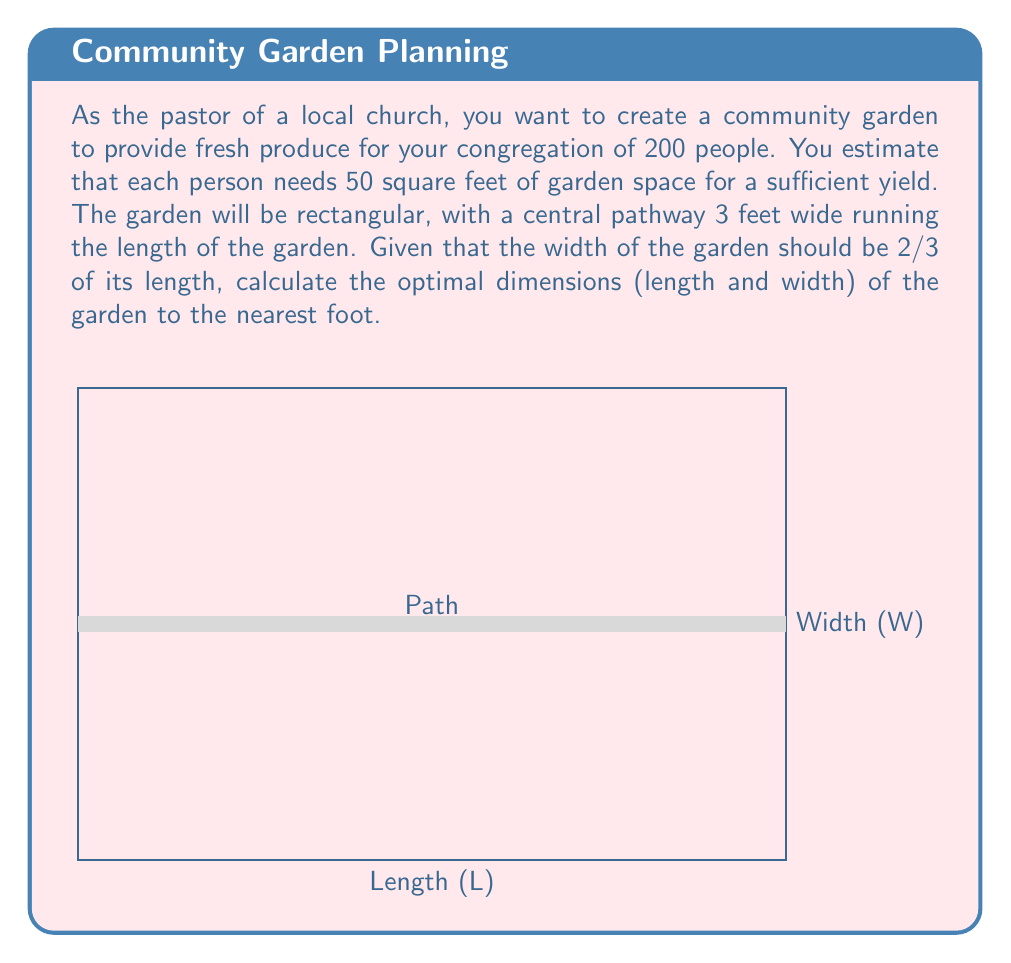Help me with this question. Let's approach this step-by-step:

1) First, calculate the total garden area needed:
   $$\text{Total Area} = 200 \text{ people} \times 50 \text{ sq ft} = 10,000 \text{ sq ft}$$

2) Let L be the length and W be the width of the garden. We're given that W = 2/3 L.

3) The area of the garden minus the path should equal 10,000 sq ft:
   $$L \times W - 3L = 10,000$$

4) Substitute W with 2/3 L:
   $$L \times (2/3L) - 3L = 10,000$$
   $$2/3L^2 - 3L = 10,000$$

5) Multiply all terms by 3:
   $$2L^2 - 9L - 30,000 = 0$$

6) This is a quadratic equation. We can solve it using the quadratic formula:
   $$L = \frac{-b \pm \sqrt{b^2 - 4ac}}{2a}$$
   where $a=2$, $b=-9$, and $c=-30,000$

7) Plugging in these values:
   $$L = \frac{9 \pm \sqrt{81 + 240,000}}{4} = \frac{9 \pm \sqrt{240,081}}{4}$$

8) Solving this:
   $$L \approx 122.5 \text{ or } -122.5$$

9) We take the positive value and round to the nearest foot:
   $$L = 123 \text{ ft}$$

10) Calculate W using W = 2/3 L:
    $$W = 2/3 \times 123 = 82 \text{ ft}$$

Therefore, the optimal dimensions are 123 ft long and 82 ft wide.
Answer: 123 ft × 82 ft 